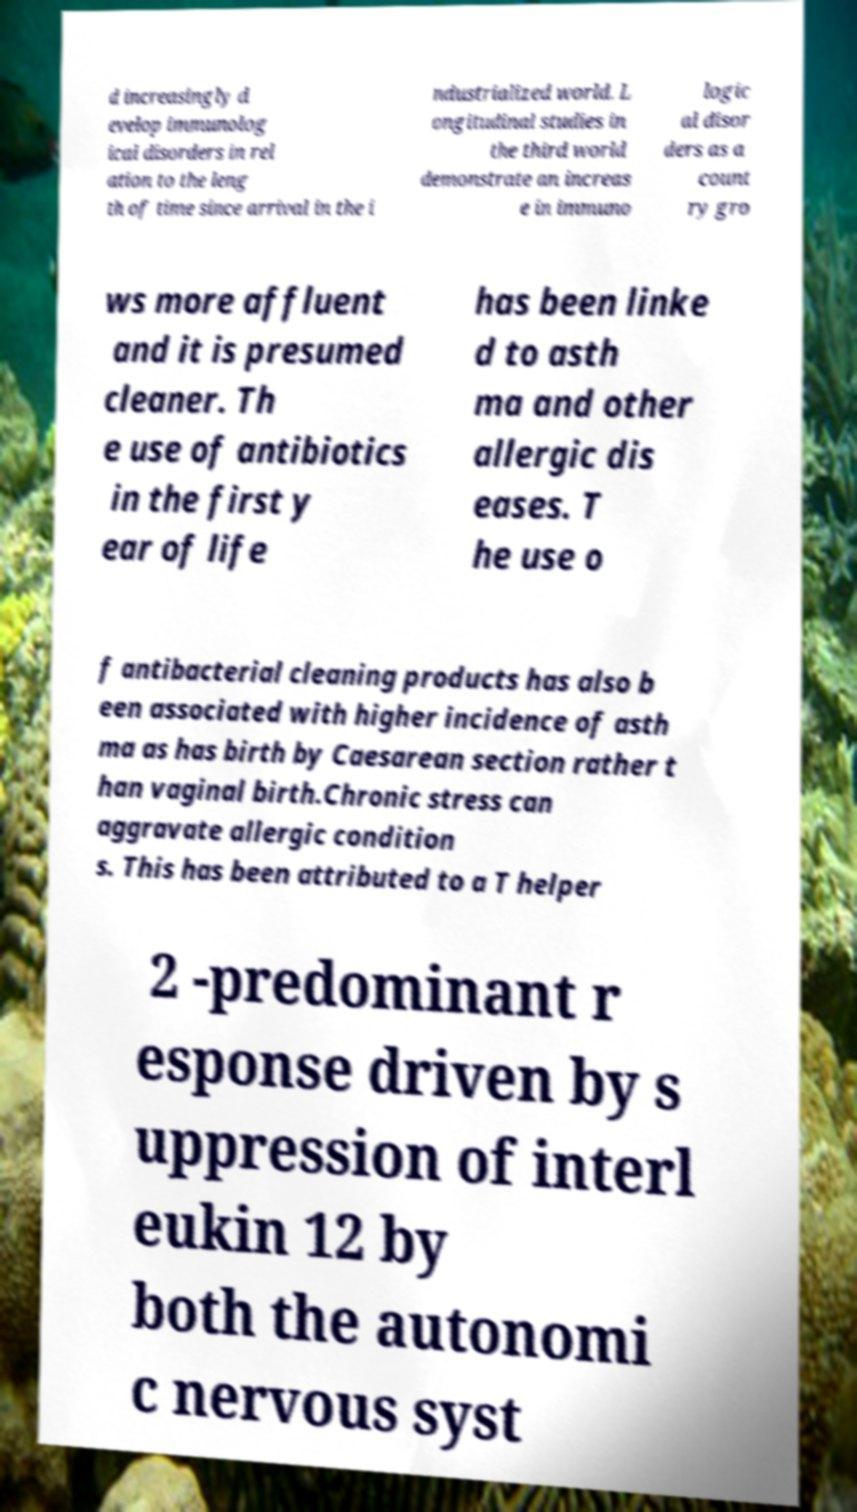Can you read and provide the text displayed in the image?This photo seems to have some interesting text. Can you extract and type it out for me? d increasingly d evelop immunolog ical disorders in rel ation to the leng th of time since arrival in the i ndustrialized world. L ongitudinal studies in the third world demonstrate an increas e in immuno logic al disor ders as a count ry gro ws more affluent and it is presumed cleaner. Th e use of antibiotics in the first y ear of life has been linke d to asth ma and other allergic dis eases. T he use o f antibacterial cleaning products has also b een associated with higher incidence of asth ma as has birth by Caesarean section rather t han vaginal birth.Chronic stress can aggravate allergic condition s. This has been attributed to a T helper 2 -predominant r esponse driven by s uppression of interl eukin 12 by both the autonomi c nervous syst 